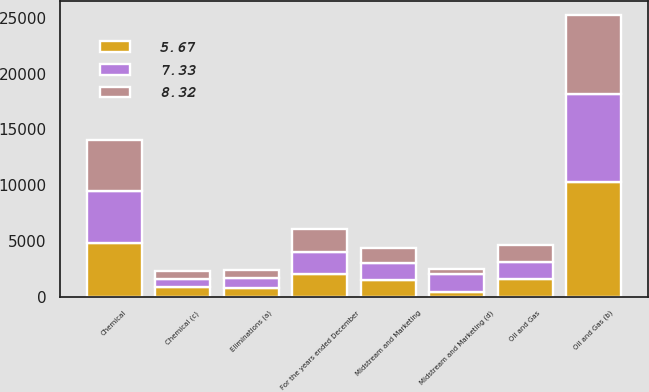Convert chart. <chart><loc_0><loc_0><loc_500><loc_500><stacked_bar_chart><ecel><fcel>For the years ended December<fcel>Oil and Gas<fcel>Chemical<fcel>Midstream and Marketing<fcel>Eliminations (a)<fcel>Oil and Gas (b)<fcel>Chemical (c)<fcel>Midstream and Marketing (d)<nl><fcel>7.33<fcel>2013<fcel>1538<fcel>4673<fcel>1538<fcel>888<fcel>7894<fcel>743<fcel>1573<nl><fcel>8.32<fcel>2012<fcel>1538<fcel>4580<fcel>1399<fcel>713<fcel>7095<fcel>720<fcel>439<nl><fcel>5.67<fcel>2011<fcel>1538<fcel>4815<fcel>1447<fcel>742<fcel>10241<fcel>861<fcel>448<nl></chart> 